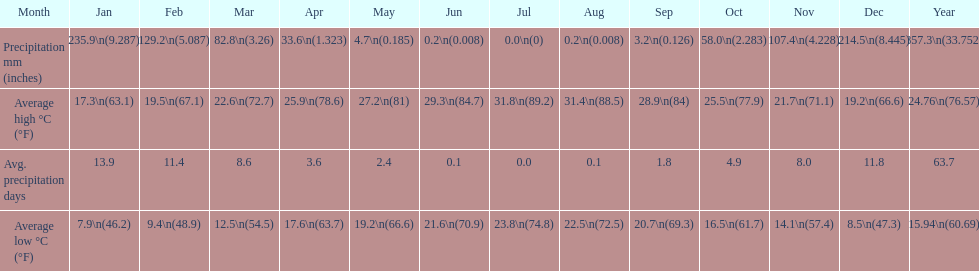Which country is haifa in? Israel. 